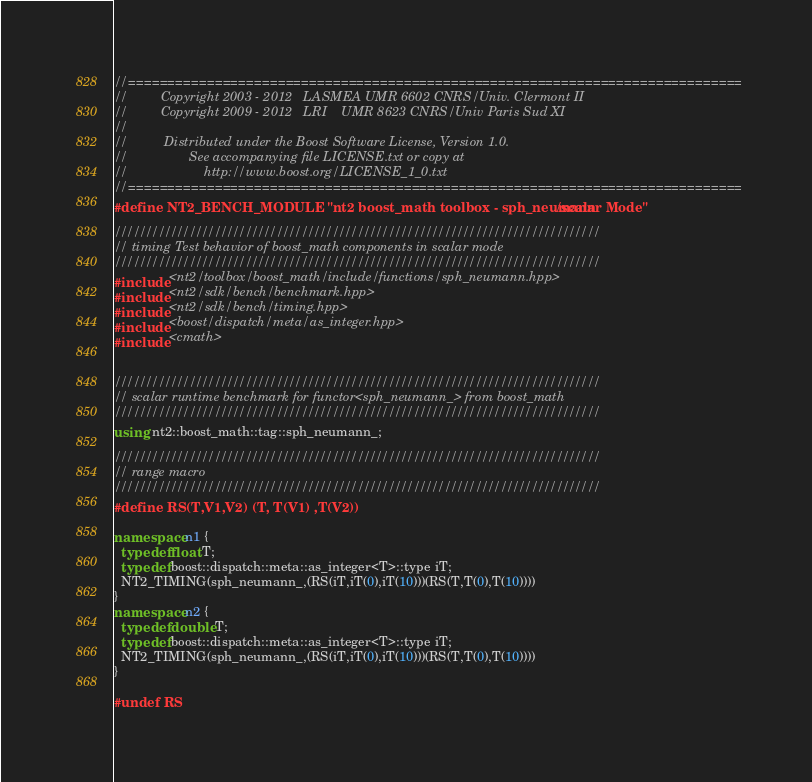<code> <loc_0><loc_0><loc_500><loc_500><_C++_>//==============================================================================
//         Copyright 2003 - 2012   LASMEA UMR 6602 CNRS/Univ. Clermont II
//         Copyright 2009 - 2012   LRI    UMR 8623 CNRS/Univ Paris Sud XI
//
//          Distributed under the Boost Software License, Version 1.0.
//                 See accompanying file LICENSE.txt or copy at
//                     http://www.boost.org/LICENSE_1_0.txt
//==============================================================================
#define NT2_BENCH_MODULE "nt2 boost_math toolbox - sph_neumann/scalar Mode"

//////////////////////////////////////////////////////////////////////////////
// timing Test behavior of boost_math components in scalar mode
//////////////////////////////////////////////////////////////////////////////
#include <nt2/toolbox/boost_math/include/functions/sph_neumann.hpp>
#include <nt2/sdk/bench/benchmark.hpp>
#include <nt2/sdk/bench/timing.hpp>
#include <boost/dispatch/meta/as_integer.hpp>
#include <cmath>


//////////////////////////////////////////////////////////////////////////////
// scalar runtime benchmark for functor<sph_neumann_> from boost_math
//////////////////////////////////////////////////////////////////////////////
using nt2::boost_math::tag::sph_neumann_;

//////////////////////////////////////////////////////////////////////////////
// range macro
//////////////////////////////////////////////////////////////////////////////
#define RS(T,V1,V2) (T, T(V1) ,T(V2))

namespace n1 {
  typedef float T;
  typedef boost::dispatch::meta::as_integer<T>::type iT;
  NT2_TIMING(sph_neumann_,(RS(iT,iT(0),iT(10)))(RS(T,T(0),T(10))))
}
namespace n2 {
  typedef double T;
  typedef boost::dispatch::meta::as_integer<T>::type iT;
  NT2_TIMING(sph_neumann_,(RS(iT,iT(0),iT(10)))(RS(T,T(0),T(10))))
}

#undef RS
</code> 